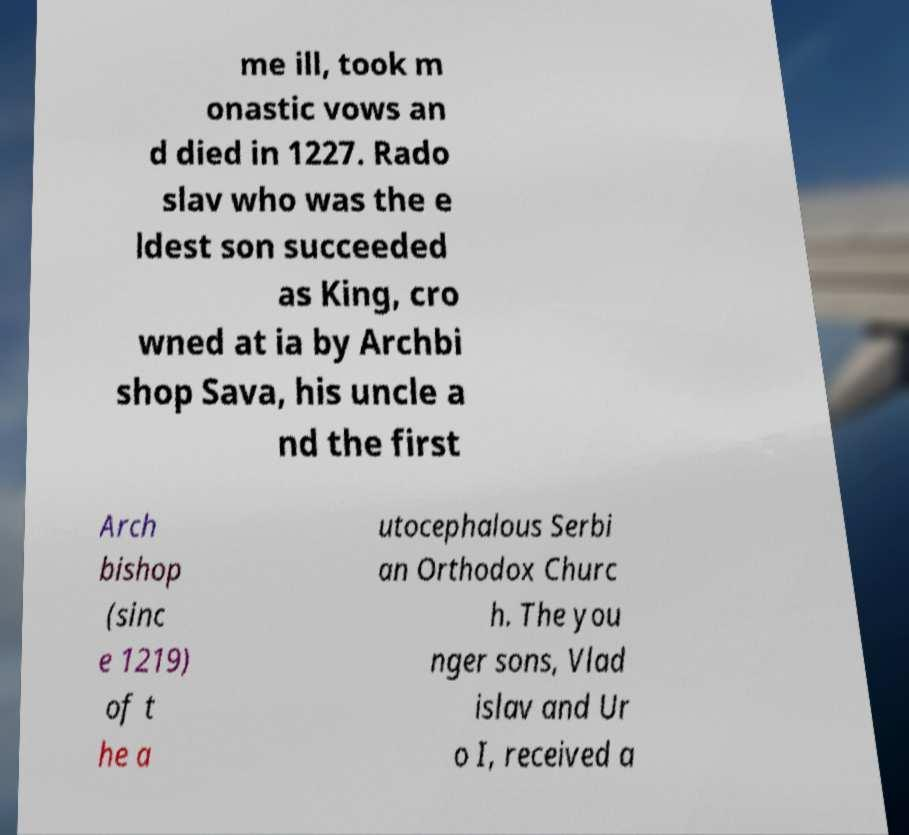Please read and relay the text visible in this image. What does it say? me ill, took m onastic vows an d died in 1227. Rado slav who was the e ldest son succeeded as King, cro wned at ia by Archbi shop Sava, his uncle a nd the first Arch bishop (sinc e 1219) of t he a utocephalous Serbi an Orthodox Churc h. The you nger sons, Vlad islav and Ur o I, received a 